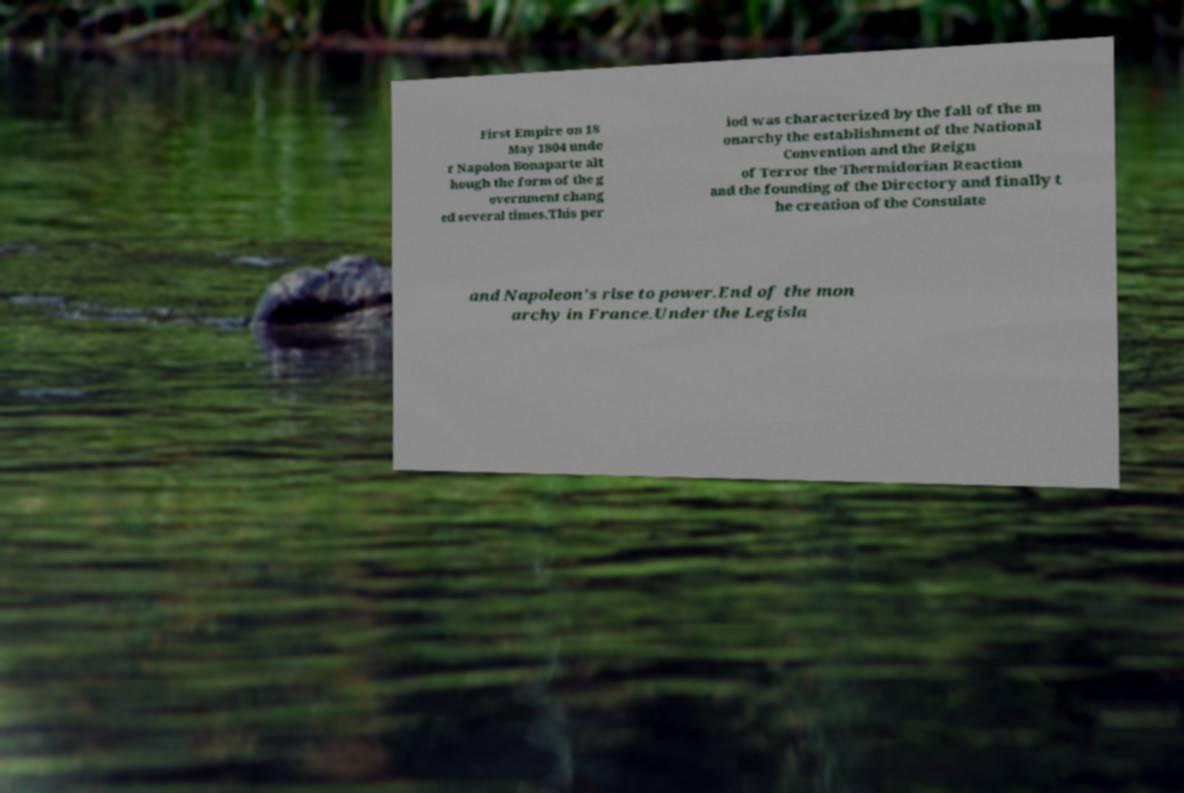Can you accurately transcribe the text from the provided image for me? First Empire on 18 May 1804 unde r Napolon Bonaparte alt hough the form of the g overnment chang ed several times.This per iod was characterized by the fall of the m onarchy the establishment of the National Convention and the Reign of Terror the Thermidorian Reaction and the founding of the Directory and finally t he creation of the Consulate and Napoleon's rise to power.End of the mon archy in France.Under the Legisla 